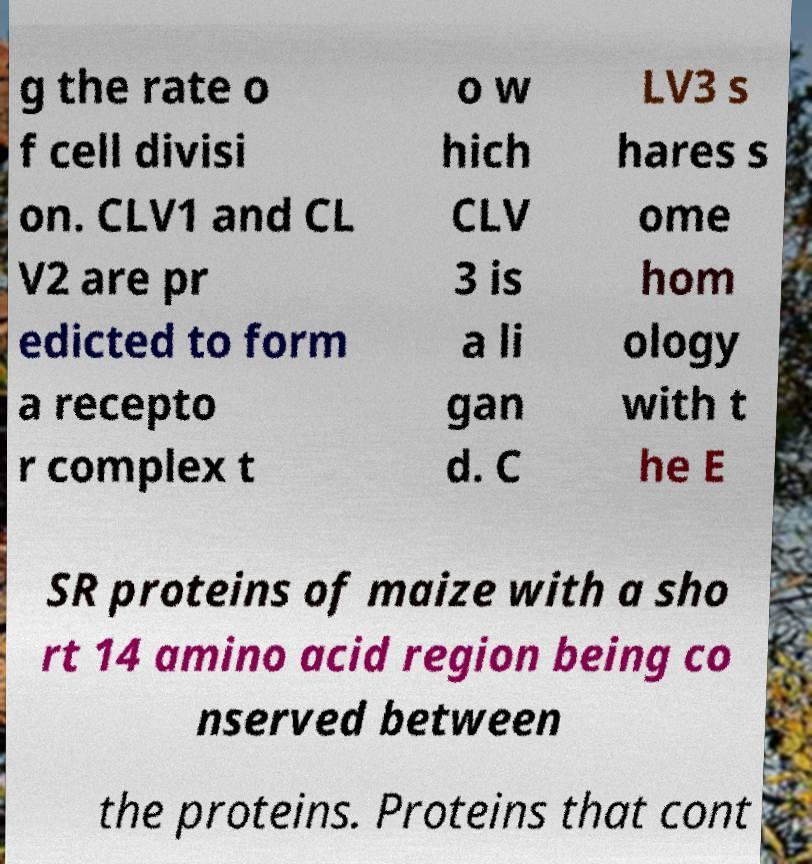Could you extract and type out the text from this image? g the rate o f cell divisi on. CLV1 and CL V2 are pr edicted to form a recepto r complex t o w hich CLV 3 is a li gan d. C LV3 s hares s ome hom ology with t he E SR proteins of maize with a sho rt 14 amino acid region being co nserved between the proteins. Proteins that cont 